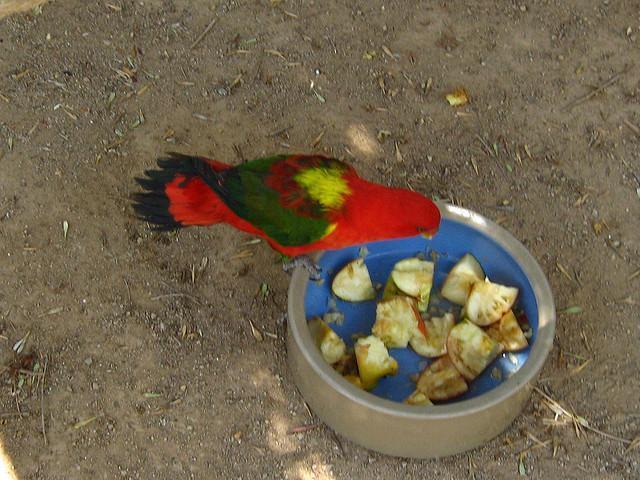Does the image validate the caption "The bowl is below the bird."?
Answer yes or no. Yes. Does the caption "The bird is on the bowl." correctly depict the image?
Answer yes or no. Yes. 